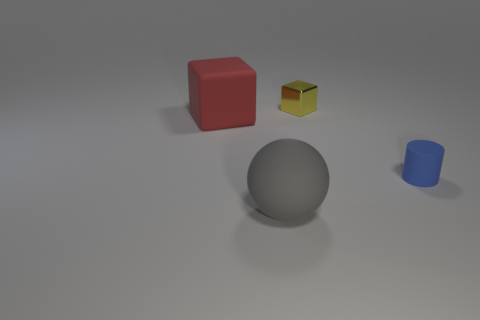The big sphere is what color?
Your answer should be very brief. Gray. What color is the other large object that is the same shape as the yellow shiny object?
Make the answer very short. Red. What number of big red things are the same shape as the yellow shiny object?
Your response must be concise. 1. What number of things are either small blue rubber cylinders or things that are in front of the small yellow shiny object?
Provide a succinct answer. 3. How big is the rubber thing that is both on the left side of the blue matte thing and in front of the big red cube?
Your answer should be very brief. Large. Are there any things on the right side of the small yellow thing?
Offer a terse response. Yes. There is a big red rubber block that is in front of the metallic block; is there a small thing that is in front of it?
Offer a terse response. Yes. Are there the same number of metallic cubes in front of the big matte sphere and small yellow cubes that are behind the large red rubber thing?
Keep it short and to the point. No. The tiny object that is the same material as the red block is what color?
Give a very brief answer. Blue. Is there a gray sphere that has the same material as the blue object?
Provide a succinct answer. Yes. 